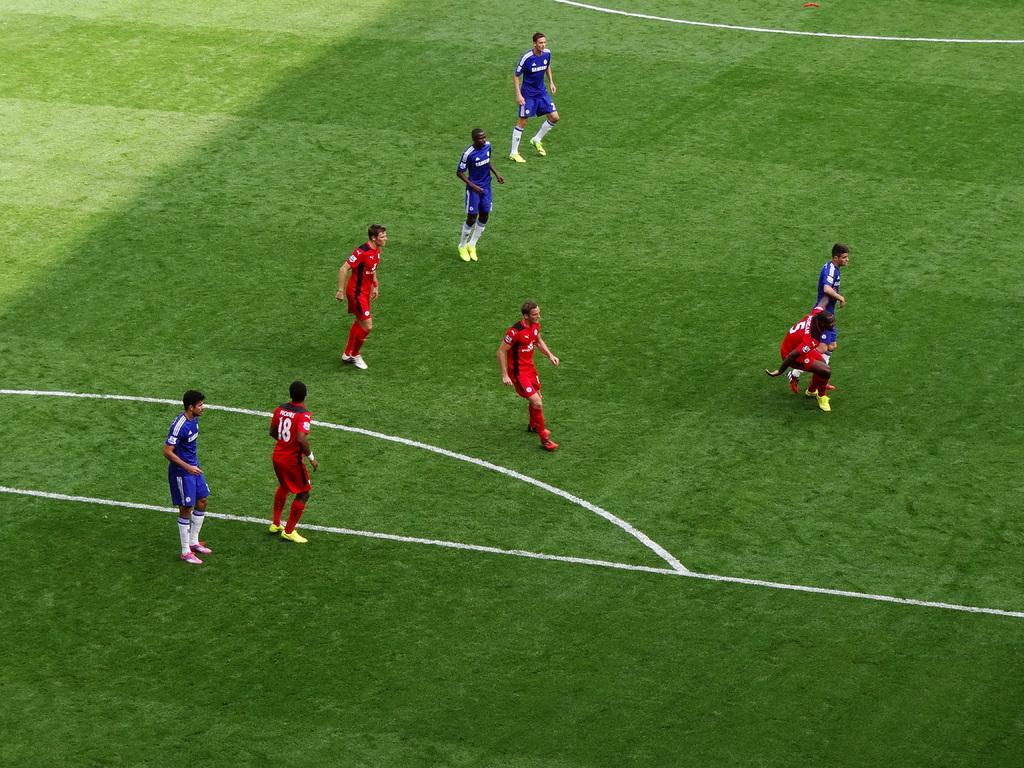What is the number on the red jersey?
Offer a very short reply. 18. 